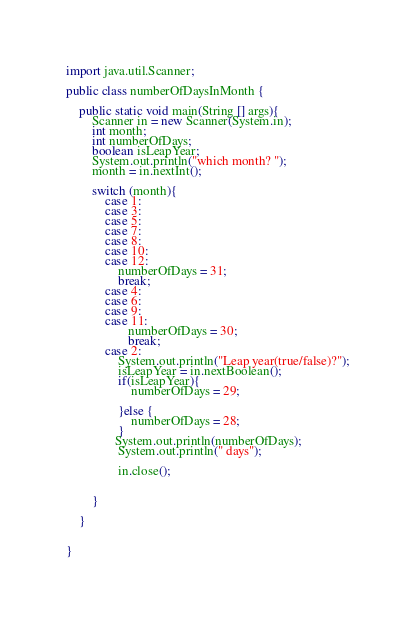Convert code to text. <code><loc_0><loc_0><loc_500><loc_500><_Java_>
import java.util.Scanner;

public class numberOfDaysInMonth {

    public static void main(String [] args){
        Scanner in = new Scanner(System.in);
        int month;
        int numberOfDays;
        boolean isLeapYear;
        System.out.println("which month? ");
        month = in.nextInt();

        switch (month){
            case 1:
            case 3:
            case 5:
            case 7:
            case 8:
            case 10:
            case 12:
                numberOfDays = 31;
                break;
            case 4:
            case 6:
            case 9:
            case 11:
                   numberOfDays = 30;
                   break;
            case 2:
                System.out.println("Leap year(true/false)?");
                isLeapYear = in.nextBoolean();
                if(isLeapYear){
                    numberOfDays = 29;

                }else {
                    numberOfDays = 28;
                }
               System.out.println(numberOfDays);
                System.out.println(" days");

                in.close();


        }

    }


}
</code> 